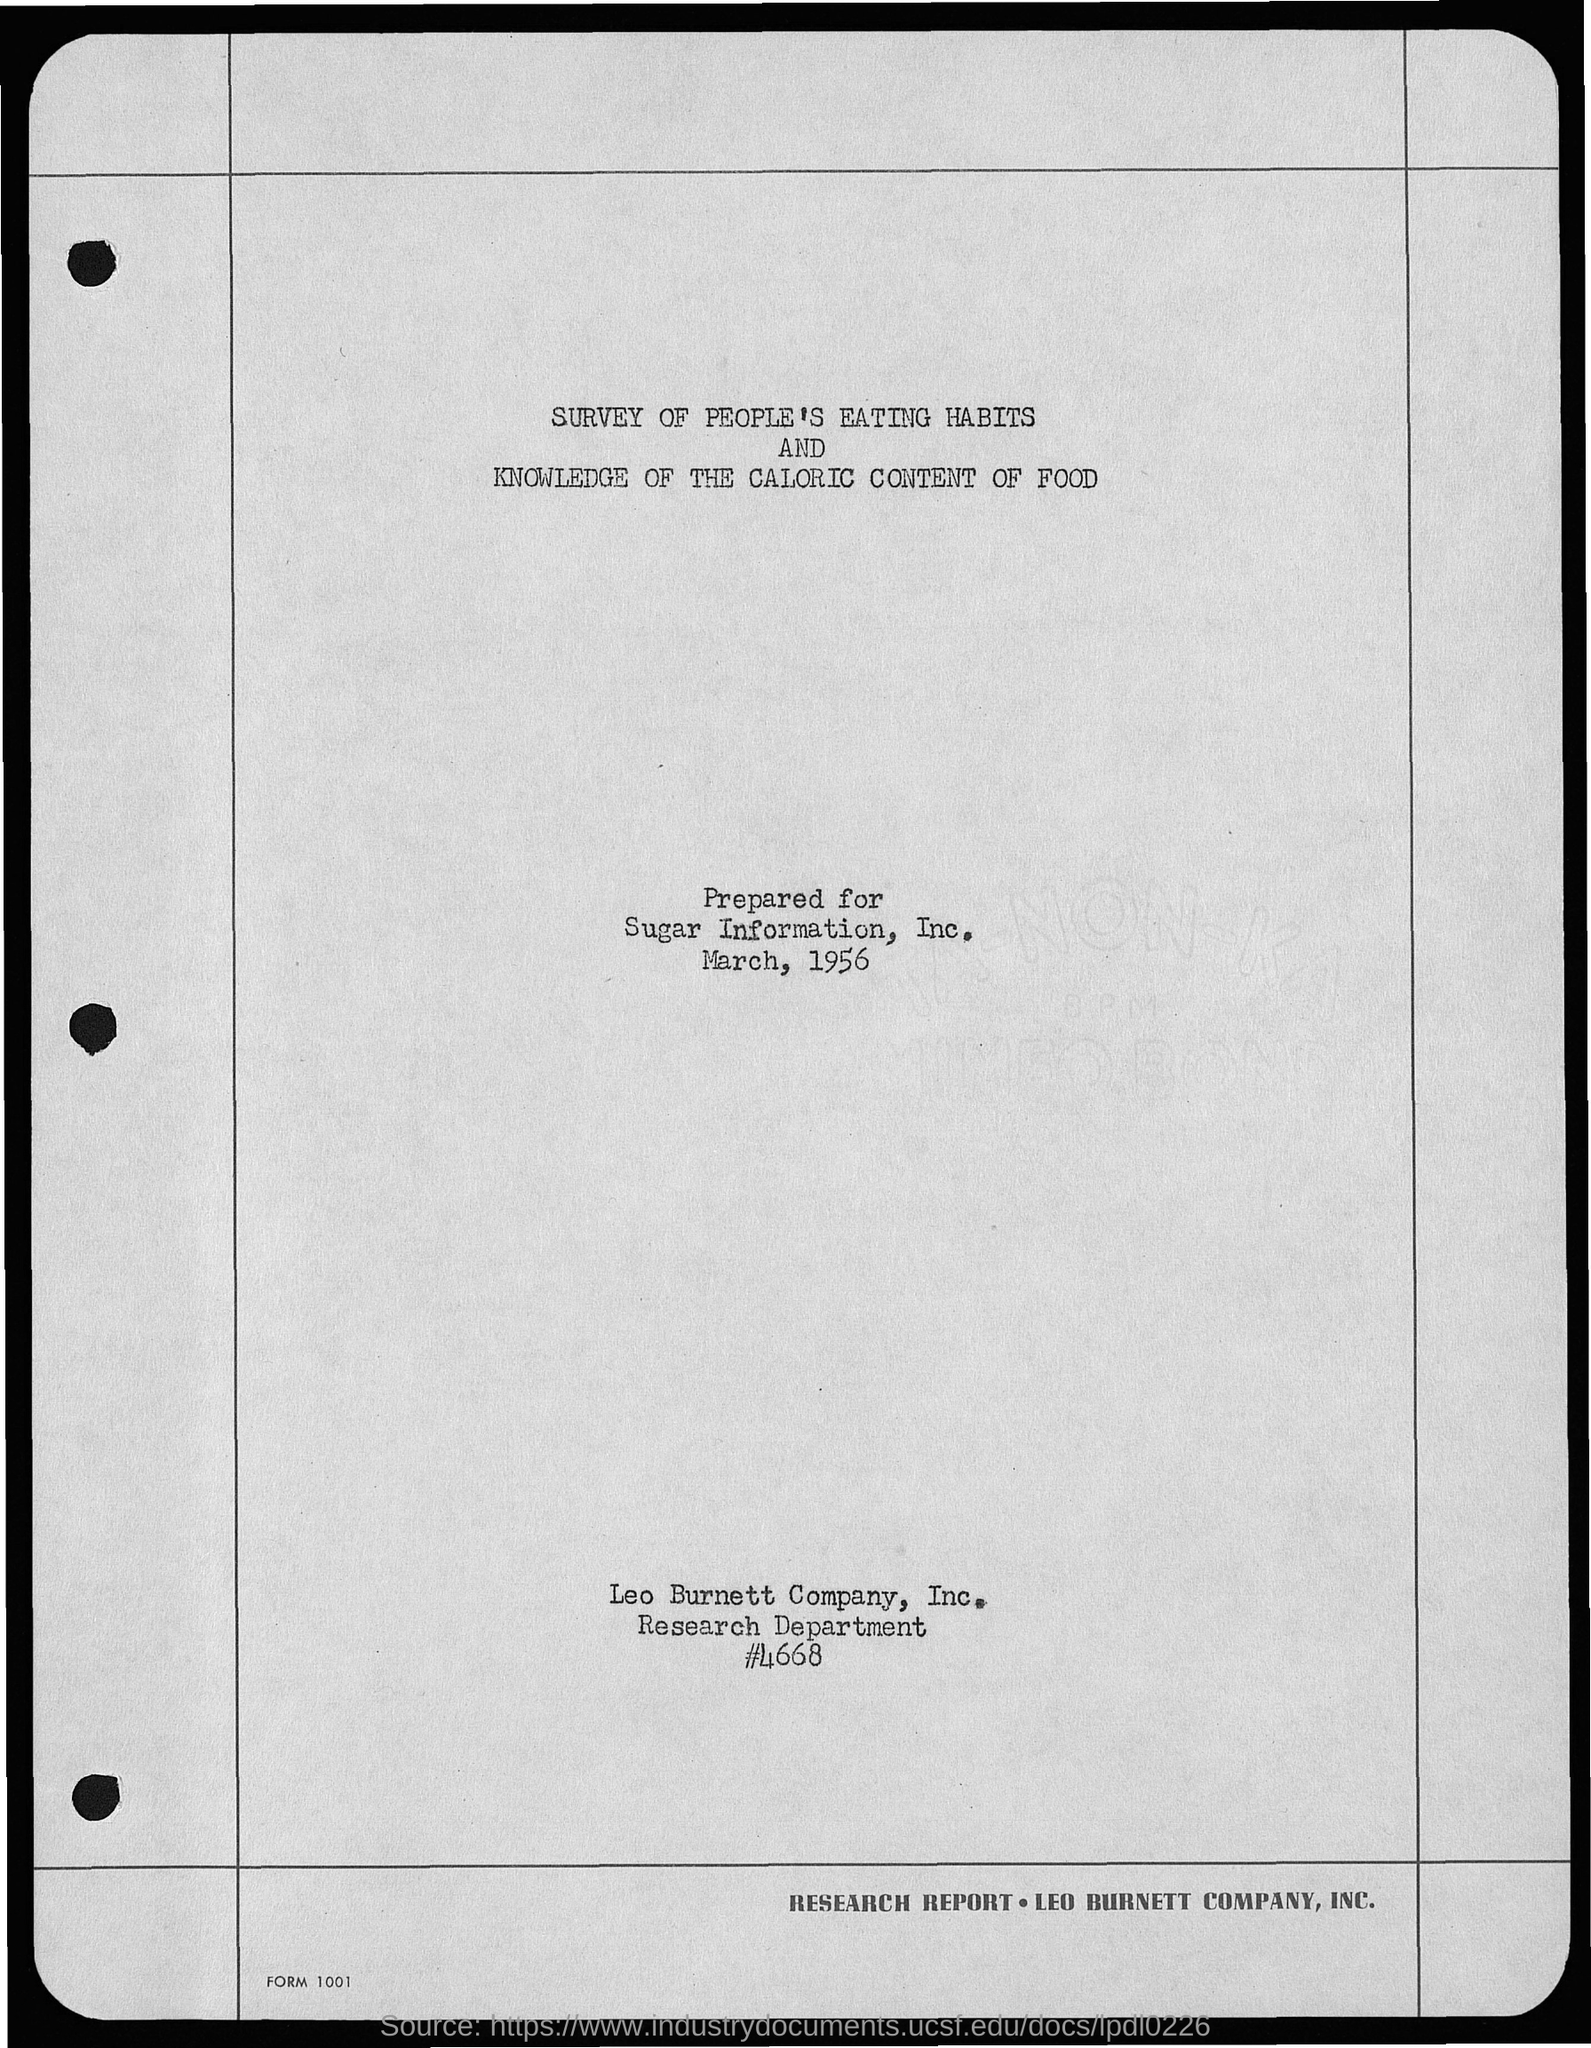To whom this letter was prepared as mentioned in the given page ?
Keep it short and to the point. Sugar information, inc. What is the month mentioned in the given page ?
Your answer should be compact. March. What is the year mentioned in the given page ?
Give a very brief answer. 1956. What is the name of the department mentioned in the given page ?
Offer a terse response. Research department. 